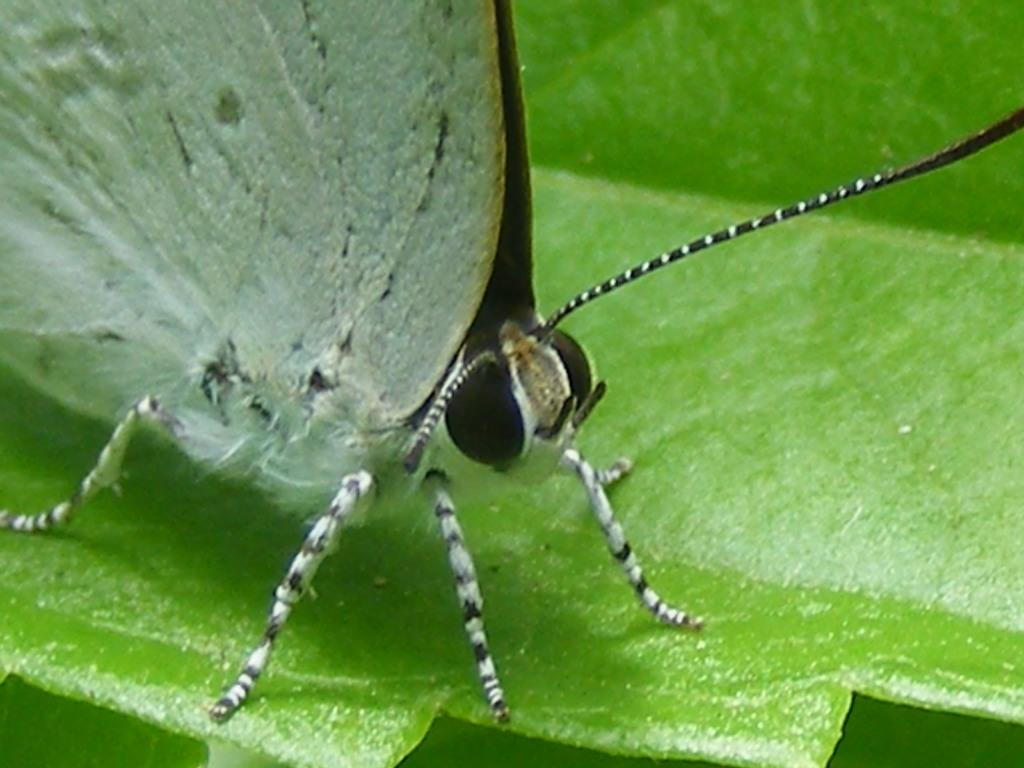What is the main subject of the image? There is a butterfly in the image. Where is the butterfly located? The butterfly is on a leaf. What type of army is depicted in the image? There is no army present in the image; it features a butterfly on a leaf. How many candles are on the birthday cake in the image? There is no birthday cake present in the image; it features a butterfly on a leaf. 